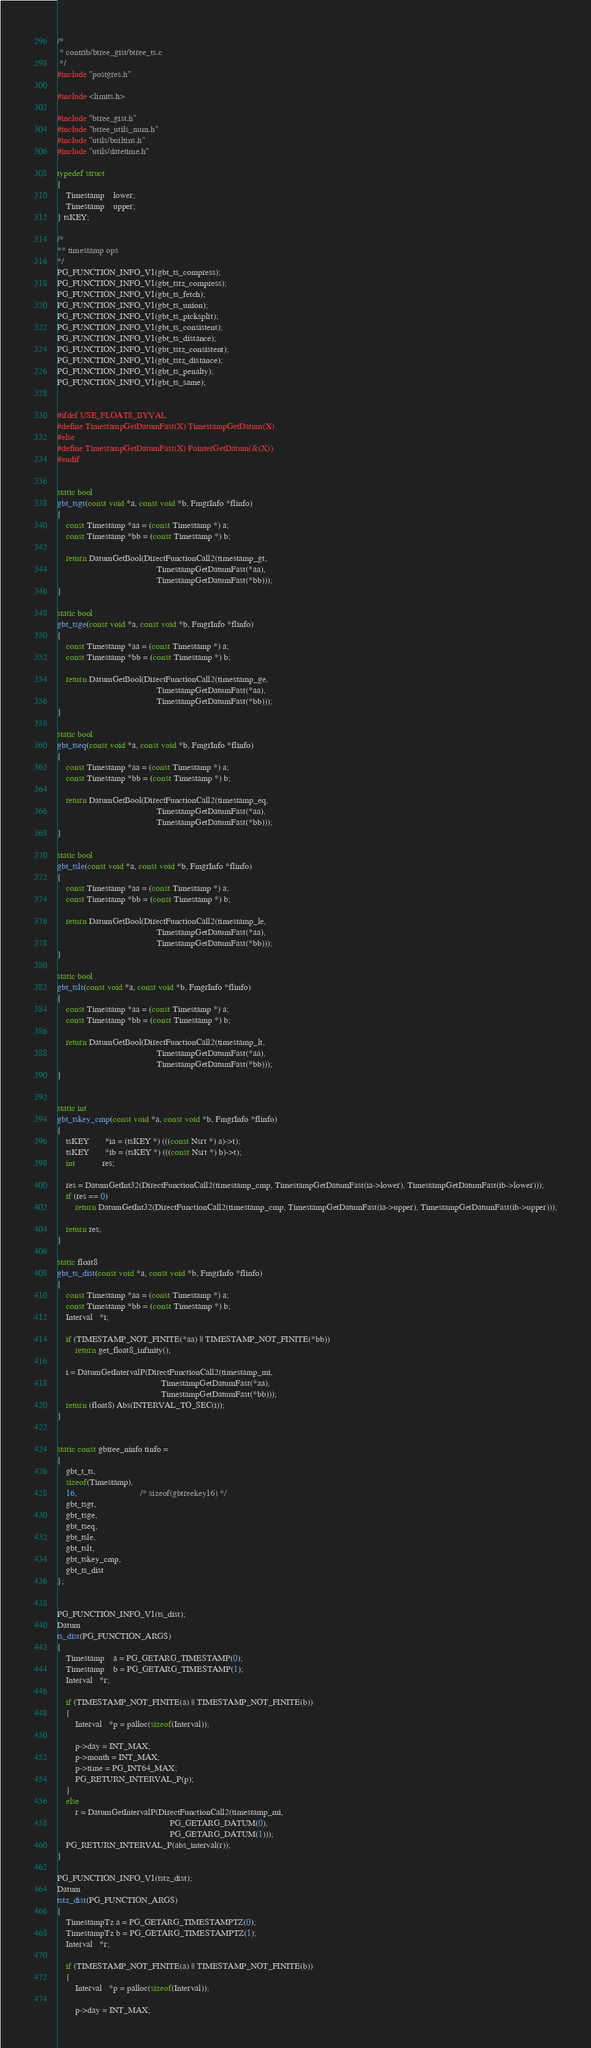Convert code to text. <code><loc_0><loc_0><loc_500><loc_500><_C_>/*
 * contrib/btree_gist/btree_ts.c
 */
#include "postgres.h"

#include <limits.h>

#include "btree_gist.h"
#include "btree_utils_num.h"
#include "utils/builtins.h"
#include "utils/datetime.h"

typedef struct
{
    Timestamp    lower;
    Timestamp    upper;
} tsKEY;

/*
** timestamp ops
*/
PG_FUNCTION_INFO_V1(gbt_ts_compress);
PG_FUNCTION_INFO_V1(gbt_tstz_compress);
PG_FUNCTION_INFO_V1(gbt_ts_fetch);
PG_FUNCTION_INFO_V1(gbt_ts_union);
PG_FUNCTION_INFO_V1(gbt_ts_picksplit);
PG_FUNCTION_INFO_V1(gbt_ts_consistent);
PG_FUNCTION_INFO_V1(gbt_ts_distance);
PG_FUNCTION_INFO_V1(gbt_tstz_consistent);
PG_FUNCTION_INFO_V1(gbt_tstz_distance);
PG_FUNCTION_INFO_V1(gbt_ts_penalty);
PG_FUNCTION_INFO_V1(gbt_ts_same);


#ifdef USE_FLOAT8_BYVAL
#define TimestampGetDatumFast(X) TimestampGetDatum(X)
#else
#define TimestampGetDatumFast(X) PointerGetDatum(&(X))
#endif


static bool
gbt_tsgt(const void *a, const void *b, FmgrInfo *flinfo)
{
    const Timestamp *aa = (const Timestamp *) a;
    const Timestamp *bb = (const Timestamp *) b;

    return DatumGetBool(DirectFunctionCall2(timestamp_gt,
                                            TimestampGetDatumFast(*aa),
                                            TimestampGetDatumFast(*bb)));
}

static bool
gbt_tsge(const void *a, const void *b, FmgrInfo *flinfo)
{
    const Timestamp *aa = (const Timestamp *) a;
    const Timestamp *bb = (const Timestamp *) b;

    return DatumGetBool(DirectFunctionCall2(timestamp_ge,
                                            TimestampGetDatumFast(*aa),
                                            TimestampGetDatumFast(*bb)));
}

static bool
gbt_tseq(const void *a, const void *b, FmgrInfo *flinfo)
{
    const Timestamp *aa = (const Timestamp *) a;
    const Timestamp *bb = (const Timestamp *) b;

    return DatumGetBool(DirectFunctionCall2(timestamp_eq,
                                            TimestampGetDatumFast(*aa),
                                            TimestampGetDatumFast(*bb)));
}

static bool
gbt_tsle(const void *a, const void *b, FmgrInfo *flinfo)
{
    const Timestamp *aa = (const Timestamp *) a;
    const Timestamp *bb = (const Timestamp *) b;

    return DatumGetBool(DirectFunctionCall2(timestamp_le,
                                            TimestampGetDatumFast(*aa),
                                            TimestampGetDatumFast(*bb)));
}

static bool
gbt_tslt(const void *a, const void *b, FmgrInfo *flinfo)
{
    const Timestamp *aa = (const Timestamp *) a;
    const Timestamp *bb = (const Timestamp *) b;

    return DatumGetBool(DirectFunctionCall2(timestamp_lt,
                                            TimestampGetDatumFast(*aa),
                                            TimestampGetDatumFast(*bb)));
}


static int
gbt_tskey_cmp(const void *a, const void *b, FmgrInfo *flinfo)
{
    tsKEY       *ia = (tsKEY *) (((const Nsrt *) a)->t);
    tsKEY       *ib = (tsKEY *) (((const Nsrt *) b)->t);
    int            res;

    res = DatumGetInt32(DirectFunctionCall2(timestamp_cmp, TimestampGetDatumFast(ia->lower), TimestampGetDatumFast(ib->lower)));
    if (res == 0)
        return DatumGetInt32(DirectFunctionCall2(timestamp_cmp, TimestampGetDatumFast(ia->upper), TimestampGetDatumFast(ib->upper)));

    return res;
}

static float8
gbt_ts_dist(const void *a, const void *b, FmgrInfo *flinfo)
{
    const Timestamp *aa = (const Timestamp *) a;
    const Timestamp *bb = (const Timestamp *) b;
    Interval   *i;

    if (TIMESTAMP_NOT_FINITE(*aa) || TIMESTAMP_NOT_FINITE(*bb))
        return get_float8_infinity();

    i = DatumGetIntervalP(DirectFunctionCall2(timestamp_mi,
                                              TimestampGetDatumFast(*aa),
                                              TimestampGetDatumFast(*bb)));
    return (float8) Abs(INTERVAL_TO_SEC(i));
}


static const gbtree_ninfo tinfo =
{
    gbt_t_ts,
    sizeof(Timestamp),
    16,                            /* sizeof(gbtreekey16) */
    gbt_tsgt,
    gbt_tsge,
    gbt_tseq,
    gbt_tsle,
    gbt_tslt,
    gbt_tskey_cmp,
    gbt_ts_dist
};


PG_FUNCTION_INFO_V1(ts_dist);
Datum
ts_dist(PG_FUNCTION_ARGS)
{
    Timestamp    a = PG_GETARG_TIMESTAMP(0);
    Timestamp    b = PG_GETARG_TIMESTAMP(1);
    Interval   *r;

    if (TIMESTAMP_NOT_FINITE(a) || TIMESTAMP_NOT_FINITE(b))
    {
        Interval   *p = palloc(sizeof(Interval));

        p->day = INT_MAX;
        p->month = INT_MAX;
        p->time = PG_INT64_MAX;
        PG_RETURN_INTERVAL_P(p);
    }
    else
        r = DatumGetIntervalP(DirectFunctionCall2(timestamp_mi,
                                                  PG_GETARG_DATUM(0),
                                                  PG_GETARG_DATUM(1)));
    PG_RETURN_INTERVAL_P(abs_interval(r));
}

PG_FUNCTION_INFO_V1(tstz_dist);
Datum
tstz_dist(PG_FUNCTION_ARGS)
{
    TimestampTz a = PG_GETARG_TIMESTAMPTZ(0);
    TimestampTz b = PG_GETARG_TIMESTAMPTZ(1);
    Interval   *r;

    if (TIMESTAMP_NOT_FINITE(a) || TIMESTAMP_NOT_FINITE(b))
    {
        Interval   *p = palloc(sizeof(Interval));

        p->day = INT_MAX;</code> 